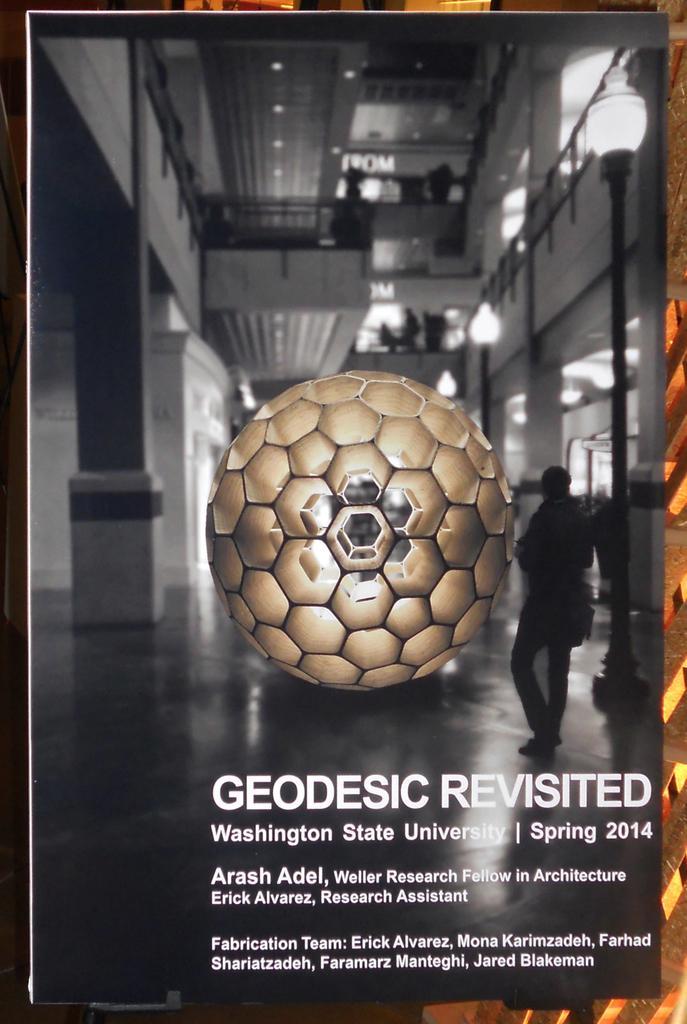In one or two sentences, can you explain what this image depicts? In this picture there is a photo frame which has an object and something written below it. 